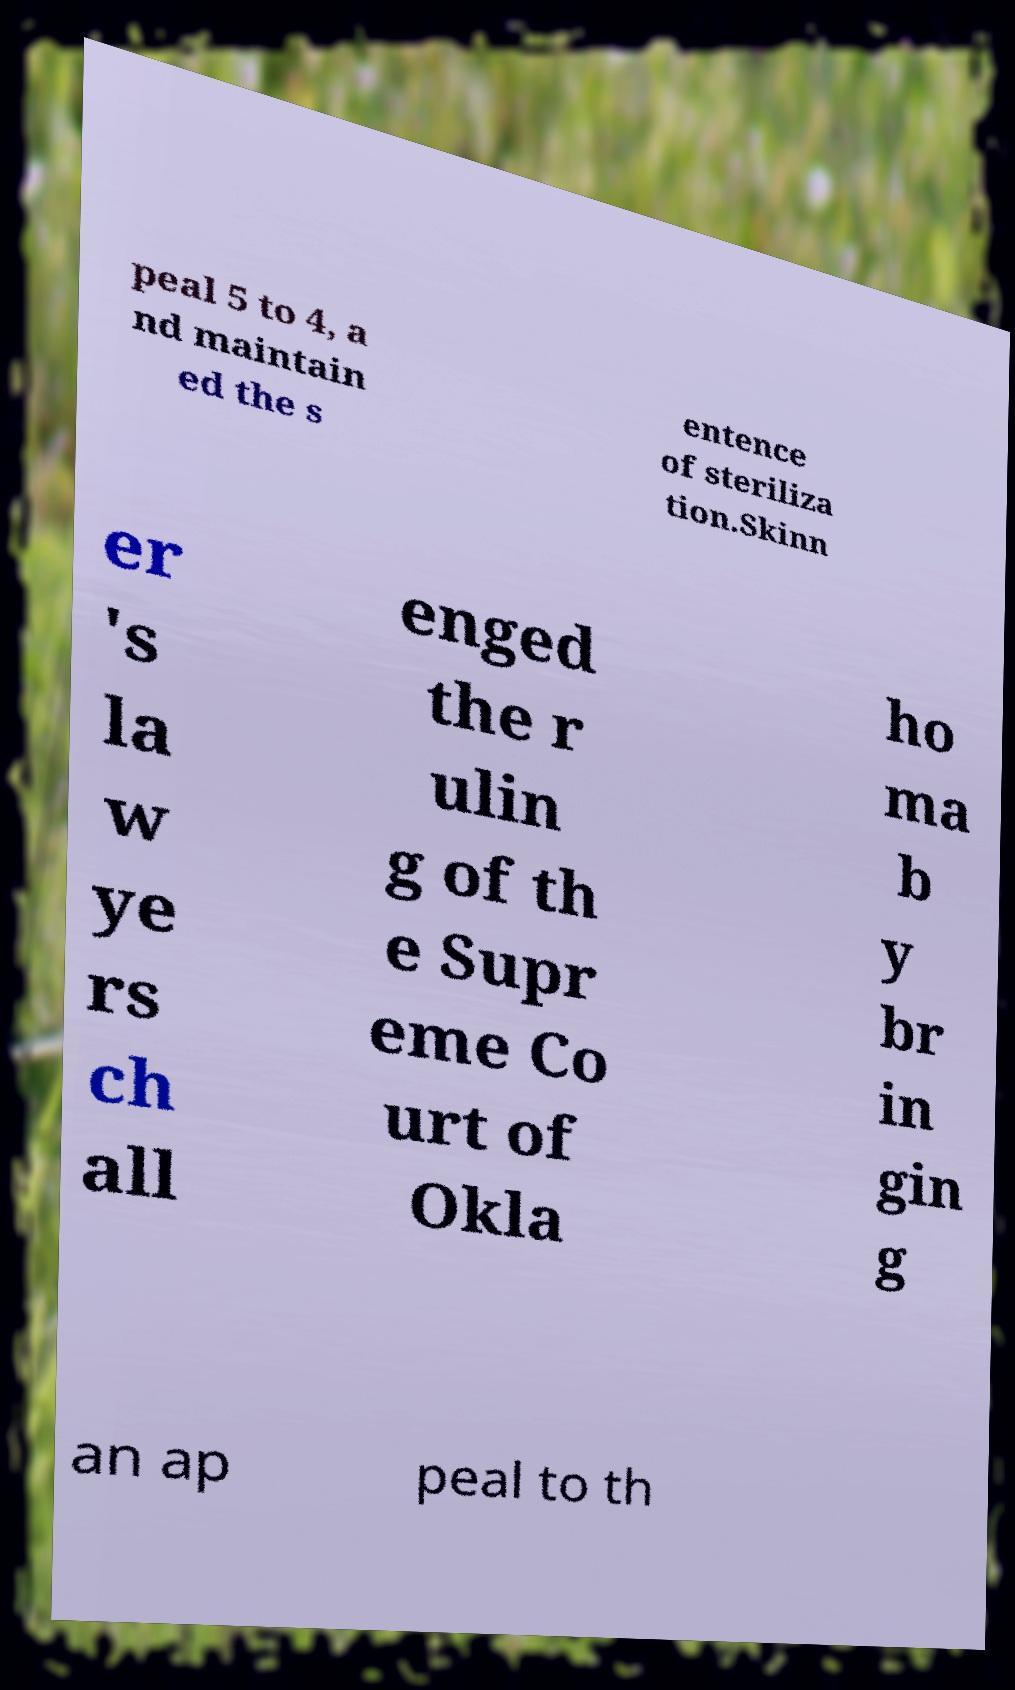I need the written content from this picture converted into text. Can you do that? peal 5 to 4, a nd maintain ed the s entence of steriliza tion.Skinn er 's la w ye rs ch all enged the r ulin g of th e Supr eme Co urt of Okla ho ma b y br in gin g an ap peal to th 